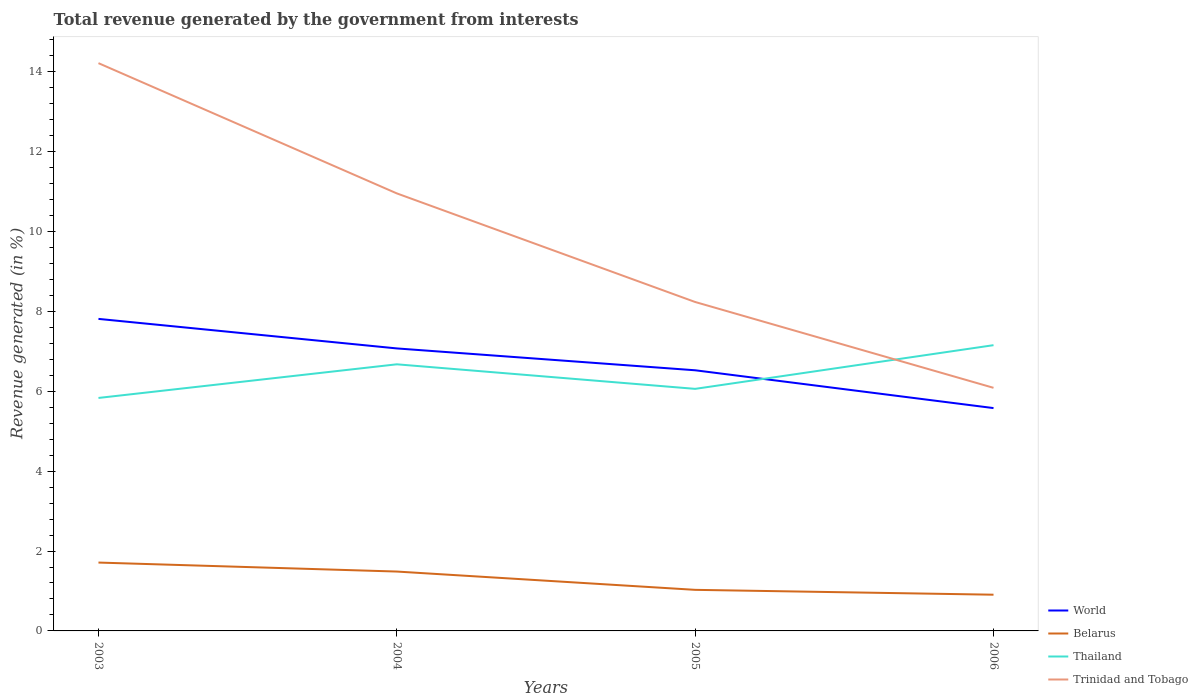Across all years, what is the maximum total revenue generated in Trinidad and Tobago?
Make the answer very short. 6.09. In which year was the total revenue generated in Trinidad and Tobago maximum?
Give a very brief answer. 2006. What is the total total revenue generated in Trinidad and Tobago in the graph?
Your answer should be very brief. 5.98. What is the difference between the highest and the second highest total revenue generated in Belarus?
Your response must be concise. 0.8. What is the difference between the highest and the lowest total revenue generated in Belarus?
Your answer should be compact. 2. How many lines are there?
Offer a terse response. 4. How many years are there in the graph?
Provide a succinct answer. 4. Are the values on the major ticks of Y-axis written in scientific E-notation?
Ensure brevity in your answer.  No. Does the graph contain any zero values?
Give a very brief answer. No. How are the legend labels stacked?
Provide a short and direct response. Vertical. What is the title of the graph?
Provide a short and direct response. Total revenue generated by the government from interests. Does "Libya" appear as one of the legend labels in the graph?
Provide a succinct answer. No. What is the label or title of the Y-axis?
Make the answer very short. Revenue generated (in %). What is the Revenue generated (in %) in World in 2003?
Provide a succinct answer. 7.81. What is the Revenue generated (in %) of Belarus in 2003?
Keep it short and to the point. 1.71. What is the Revenue generated (in %) of Thailand in 2003?
Ensure brevity in your answer.  5.83. What is the Revenue generated (in %) in Trinidad and Tobago in 2003?
Ensure brevity in your answer.  14.21. What is the Revenue generated (in %) in World in 2004?
Make the answer very short. 7.07. What is the Revenue generated (in %) of Belarus in 2004?
Ensure brevity in your answer.  1.49. What is the Revenue generated (in %) in Thailand in 2004?
Provide a succinct answer. 6.67. What is the Revenue generated (in %) in Trinidad and Tobago in 2004?
Offer a terse response. 10.95. What is the Revenue generated (in %) in World in 2005?
Your answer should be very brief. 6.52. What is the Revenue generated (in %) in Belarus in 2005?
Offer a terse response. 1.03. What is the Revenue generated (in %) in Thailand in 2005?
Keep it short and to the point. 6.06. What is the Revenue generated (in %) in Trinidad and Tobago in 2005?
Provide a short and direct response. 8.23. What is the Revenue generated (in %) of World in 2006?
Give a very brief answer. 5.58. What is the Revenue generated (in %) in Belarus in 2006?
Your answer should be compact. 0.91. What is the Revenue generated (in %) in Thailand in 2006?
Your answer should be very brief. 7.15. What is the Revenue generated (in %) of Trinidad and Tobago in 2006?
Your response must be concise. 6.09. Across all years, what is the maximum Revenue generated (in %) of World?
Offer a terse response. 7.81. Across all years, what is the maximum Revenue generated (in %) in Belarus?
Make the answer very short. 1.71. Across all years, what is the maximum Revenue generated (in %) of Thailand?
Your response must be concise. 7.15. Across all years, what is the maximum Revenue generated (in %) in Trinidad and Tobago?
Ensure brevity in your answer.  14.21. Across all years, what is the minimum Revenue generated (in %) in World?
Give a very brief answer. 5.58. Across all years, what is the minimum Revenue generated (in %) in Belarus?
Ensure brevity in your answer.  0.91. Across all years, what is the minimum Revenue generated (in %) of Thailand?
Your response must be concise. 5.83. Across all years, what is the minimum Revenue generated (in %) of Trinidad and Tobago?
Provide a short and direct response. 6.09. What is the total Revenue generated (in %) in World in the graph?
Keep it short and to the point. 26.99. What is the total Revenue generated (in %) of Belarus in the graph?
Your response must be concise. 5.13. What is the total Revenue generated (in %) of Thailand in the graph?
Offer a terse response. 25.72. What is the total Revenue generated (in %) in Trinidad and Tobago in the graph?
Make the answer very short. 39.49. What is the difference between the Revenue generated (in %) of World in 2003 and that in 2004?
Give a very brief answer. 0.74. What is the difference between the Revenue generated (in %) of Belarus in 2003 and that in 2004?
Your answer should be very brief. 0.22. What is the difference between the Revenue generated (in %) of Thailand in 2003 and that in 2004?
Give a very brief answer. -0.84. What is the difference between the Revenue generated (in %) in Trinidad and Tobago in 2003 and that in 2004?
Your answer should be compact. 3.26. What is the difference between the Revenue generated (in %) in World in 2003 and that in 2005?
Offer a terse response. 1.29. What is the difference between the Revenue generated (in %) of Belarus in 2003 and that in 2005?
Give a very brief answer. 0.68. What is the difference between the Revenue generated (in %) of Thailand in 2003 and that in 2005?
Your answer should be very brief. -0.23. What is the difference between the Revenue generated (in %) in Trinidad and Tobago in 2003 and that in 2005?
Ensure brevity in your answer.  5.98. What is the difference between the Revenue generated (in %) of World in 2003 and that in 2006?
Provide a short and direct response. 2.23. What is the difference between the Revenue generated (in %) in Belarus in 2003 and that in 2006?
Your answer should be compact. 0.8. What is the difference between the Revenue generated (in %) of Thailand in 2003 and that in 2006?
Offer a very short reply. -1.32. What is the difference between the Revenue generated (in %) of Trinidad and Tobago in 2003 and that in 2006?
Offer a very short reply. 8.13. What is the difference between the Revenue generated (in %) of World in 2004 and that in 2005?
Ensure brevity in your answer.  0.55. What is the difference between the Revenue generated (in %) of Belarus in 2004 and that in 2005?
Give a very brief answer. 0.46. What is the difference between the Revenue generated (in %) of Thailand in 2004 and that in 2005?
Provide a short and direct response. 0.61. What is the difference between the Revenue generated (in %) in Trinidad and Tobago in 2004 and that in 2005?
Make the answer very short. 2.72. What is the difference between the Revenue generated (in %) in World in 2004 and that in 2006?
Keep it short and to the point. 1.49. What is the difference between the Revenue generated (in %) of Belarus in 2004 and that in 2006?
Provide a succinct answer. 0.58. What is the difference between the Revenue generated (in %) of Thailand in 2004 and that in 2006?
Offer a terse response. -0.48. What is the difference between the Revenue generated (in %) of Trinidad and Tobago in 2004 and that in 2006?
Give a very brief answer. 4.87. What is the difference between the Revenue generated (in %) in World in 2005 and that in 2006?
Offer a terse response. 0.95. What is the difference between the Revenue generated (in %) of Belarus in 2005 and that in 2006?
Your answer should be very brief. 0.12. What is the difference between the Revenue generated (in %) of Thailand in 2005 and that in 2006?
Keep it short and to the point. -1.09. What is the difference between the Revenue generated (in %) in Trinidad and Tobago in 2005 and that in 2006?
Keep it short and to the point. 2.15. What is the difference between the Revenue generated (in %) of World in 2003 and the Revenue generated (in %) of Belarus in 2004?
Provide a short and direct response. 6.33. What is the difference between the Revenue generated (in %) in World in 2003 and the Revenue generated (in %) in Thailand in 2004?
Keep it short and to the point. 1.14. What is the difference between the Revenue generated (in %) in World in 2003 and the Revenue generated (in %) in Trinidad and Tobago in 2004?
Provide a short and direct response. -3.14. What is the difference between the Revenue generated (in %) of Belarus in 2003 and the Revenue generated (in %) of Thailand in 2004?
Provide a succinct answer. -4.96. What is the difference between the Revenue generated (in %) of Belarus in 2003 and the Revenue generated (in %) of Trinidad and Tobago in 2004?
Offer a very short reply. -9.24. What is the difference between the Revenue generated (in %) of Thailand in 2003 and the Revenue generated (in %) of Trinidad and Tobago in 2004?
Your answer should be compact. -5.12. What is the difference between the Revenue generated (in %) in World in 2003 and the Revenue generated (in %) in Belarus in 2005?
Ensure brevity in your answer.  6.78. What is the difference between the Revenue generated (in %) in World in 2003 and the Revenue generated (in %) in Thailand in 2005?
Make the answer very short. 1.75. What is the difference between the Revenue generated (in %) of World in 2003 and the Revenue generated (in %) of Trinidad and Tobago in 2005?
Make the answer very short. -0.42. What is the difference between the Revenue generated (in %) of Belarus in 2003 and the Revenue generated (in %) of Thailand in 2005?
Your answer should be compact. -4.35. What is the difference between the Revenue generated (in %) in Belarus in 2003 and the Revenue generated (in %) in Trinidad and Tobago in 2005?
Offer a terse response. -6.52. What is the difference between the Revenue generated (in %) in Thailand in 2003 and the Revenue generated (in %) in Trinidad and Tobago in 2005?
Offer a terse response. -2.4. What is the difference between the Revenue generated (in %) in World in 2003 and the Revenue generated (in %) in Belarus in 2006?
Your response must be concise. 6.9. What is the difference between the Revenue generated (in %) in World in 2003 and the Revenue generated (in %) in Thailand in 2006?
Keep it short and to the point. 0.66. What is the difference between the Revenue generated (in %) of World in 2003 and the Revenue generated (in %) of Trinidad and Tobago in 2006?
Your answer should be very brief. 1.73. What is the difference between the Revenue generated (in %) in Belarus in 2003 and the Revenue generated (in %) in Thailand in 2006?
Provide a short and direct response. -5.44. What is the difference between the Revenue generated (in %) of Belarus in 2003 and the Revenue generated (in %) of Trinidad and Tobago in 2006?
Make the answer very short. -4.37. What is the difference between the Revenue generated (in %) of Thailand in 2003 and the Revenue generated (in %) of Trinidad and Tobago in 2006?
Offer a terse response. -0.25. What is the difference between the Revenue generated (in %) of World in 2004 and the Revenue generated (in %) of Belarus in 2005?
Give a very brief answer. 6.04. What is the difference between the Revenue generated (in %) in World in 2004 and the Revenue generated (in %) in Thailand in 2005?
Keep it short and to the point. 1.01. What is the difference between the Revenue generated (in %) of World in 2004 and the Revenue generated (in %) of Trinidad and Tobago in 2005?
Provide a short and direct response. -1.16. What is the difference between the Revenue generated (in %) in Belarus in 2004 and the Revenue generated (in %) in Thailand in 2005?
Give a very brief answer. -4.57. What is the difference between the Revenue generated (in %) of Belarus in 2004 and the Revenue generated (in %) of Trinidad and Tobago in 2005?
Offer a very short reply. -6.75. What is the difference between the Revenue generated (in %) of Thailand in 2004 and the Revenue generated (in %) of Trinidad and Tobago in 2005?
Make the answer very short. -1.56. What is the difference between the Revenue generated (in %) in World in 2004 and the Revenue generated (in %) in Belarus in 2006?
Offer a terse response. 6.17. What is the difference between the Revenue generated (in %) of World in 2004 and the Revenue generated (in %) of Thailand in 2006?
Your response must be concise. -0.08. What is the difference between the Revenue generated (in %) of World in 2004 and the Revenue generated (in %) of Trinidad and Tobago in 2006?
Offer a very short reply. 0.99. What is the difference between the Revenue generated (in %) of Belarus in 2004 and the Revenue generated (in %) of Thailand in 2006?
Your response must be concise. -5.67. What is the difference between the Revenue generated (in %) in Belarus in 2004 and the Revenue generated (in %) in Trinidad and Tobago in 2006?
Give a very brief answer. -4.6. What is the difference between the Revenue generated (in %) of Thailand in 2004 and the Revenue generated (in %) of Trinidad and Tobago in 2006?
Offer a very short reply. 0.59. What is the difference between the Revenue generated (in %) in World in 2005 and the Revenue generated (in %) in Belarus in 2006?
Your response must be concise. 5.62. What is the difference between the Revenue generated (in %) of World in 2005 and the Revenue generated (in %) of Thailand in 2006?
Offer a very short reply. -0.63. What is the difference between the Revenue generated (in %) of World in 2005 and the Revenue generated (in %) of Trinidad and Tobago in 2006?
Your answer should be compact. 0.44. What is the difference between the Revenue generated (in %) of Belarus in 2005 and the Revenue generated (in %) of Thailand in 2006?
Your answer should be compact. -6.13. What is the difference between the Revenue generated (in %) of Belarus in 2005 and the Revenue generated (in %) of Trinidad and Tobago in 2006?
Your response must be concise. -5.06. What is the difference between the Revenue generated (in %) of Thailand in 2005 and the Revenue generated (in %) of Trinidad and Tobago in 2006?
Keep it short and to the point. -0.03. What is the average Revenue generated (in %) in World per year?
Your answer should be compact. 6.75. What is the average Revenue generated (in %) of Belarus per year?
Provide a short and direct response. 1.28. What is the average Revenue generated (in %) in Thailand per year?
Give a very brief answer. 6.43. What is the average Revenue generated (in %) of Trinidad and Tobago per year?
Make the answer very short. 9.87. In the year 2003, what is the difference between the Revenue generated (in %) of World and Revenue generated (in %) of Belarus?
Provide a succinct answer. 6.1. In the year 2003, what is the difference between the Revenue generated (in %) in World and Revenue generated (in %) in Thailand?
Ensure brevity in your answer.  1.98. In the year 2003, what is the difference between the Revenue generated (in %) of World and Revenue generated (in %) of Trinidad and Tobago?
Offer a terse response. -6.4. In the year 2003, what is the difference between the Revenue generated (in %) in Belarus and Revenue generated (in %) in Thailand?
Provide a succinct answer. -4.12. In the year 2003, what is the difference between the Revenue generated (in %) in Belarus and Revenue generated (in %) in Trinidad and Tobago?
Give a very brief answer. -12.5. In the year 2003, what is the difference between the Revenue generated (in %) of Thailand and Revenue generated (in %) of Trinidad and Tobago?
Offer a terse response. -8.38. In the year 2004, what is the difference between the Revenue generated (in %) of World and Revenue generated (in %) of Belarus?
Your answer should be very brief. 5.59. In the year 2004, what is the difference between the Revenue generated (in %) of World and Revenue generated (in %) of Thailand?
Make the answer very short. 0.4. In the year 2004, what is the difference between the Revenue generated (in %) in World and Revenue generated (in %) in Trinidad and Tobago?
Give a very brief answer. -3.88. In the year 2004, what is the difference between the Revenue generated (in %) of Belarus and Revenue generated (in %) of Thailand?
Offer a very short reply. -5.19. In the year 2004, what is the difference between the Revenue generated (in %) in Belarus and Revenue generated (in %) in Trinidad and Tobago?
Offer a very short reply. -9.47. In the year 2004, what is the difference between the Revenue generated (in %) of Thailand and Revenue generated (in %) of Trinidad and Tobago?
Provide a short and direct response. -4.28. In the year 2005, what is the difference between the Revenue generated (in %) in World and Revenue generated (in %) in Belarus?
Provide a short and direct response. 5.5. In the year 2005, what is the difference between the Revenue generated (in %) of World and Revenue generated (in %) of Thailand?
Offer a terse response. 0.47. In the year 2005, what is the difference between the Revenue generated (in %) in World and Revenue generated (in %) in Trinidad and Tobago?
Offer a very short reply. -1.71. In the year 2005, what is the difference between the Revenue generated (in %) in Belarus and Revenue generated (in %) in Thailand?
Keep it short and to the point. -5.03. In the year 2005, what is the difference between the Revenue generated (in %) of Belarus and Revenue generated (in %) of Trinidad and Tobago?
Keep it short and to the point. -7.21. In the year 2005, what is the difference between the Revenue generated (in %) of Thailand and Revenue generated (in %) of Trinidad and Tobago?
Ensure brevity in your answer.  -2.17. In the year 2006, what is the difference between the Revenue generated (in %) in World and Revenue generated (in %) in Belarus?
Your response must be concise. 4.67. In the year 2006, what is the difference between the Revenue generated (in %) in World and Revenue generated (in %) in Thailand?
Offer a terse response. -1.58. In the year 2006, what is the difference between the Revenue generated (in %) of World and Revenue generated (in %) of Trinidad and Tobago?
Your response must be concise. -0.51. In the year 2006, what is the difference between the Revenue generated (in %) in Belarus and Revenue generated (in %) in Thailand?
Offer a terse response. -6.25. In the year 2006, what is the difference between the Revenue generated (in %) of Belarus and Revenue generated (in %) of Trinidad and Tobago?
Make the answer very short. -5.18. In the year 2006, what is the difference between the Revenue generated (in %) of Thailand and Revenue generated (in %) of Trinidad and Tobago?
Make the answer very short. 1.07. What is the ratio of the Revenue generated (in %) in World in 2003 to that in 2004?
Your answer should be compact. 1.1. What is the ratio of the Revenue generated (in %) in Belarus in 2003 to that in 2004?
Give a very brief answer. 1.15. What is the ratio of the Revenue generated (in %) in Thailand in 2003 to that in 2004?
Give a very brief answer. 0.87. What is the ratio of the Revenue generated (in %) of Trinidad and Tobago in 2003 to that in 2004?
Provide a succinct answer. 1.3. What is the ratio of the Revenue generated (in %) in World in 2003 to that in 2005?
Make the answer very short. 1.2. What is the ratio of the Revenue generated (in %) in Belarus in 2003 to that in 2005?
Provide a succinct answer. 1.66. What is the ratio of the Revenue generated (in %) of Thailand in 2003 to that in 2005?
Provide a succinct answer. 0.96. What is the ratio of the Revenue generated (in %) of Trinidad and Tobago in 2003 to that in 2005?
Give a very brief answer. 1.73. What is the ratio of the Revenue generated (in %) of World in 2003 to that in 2006?
Offer a very short reply. 1.4. What is the ratio of the Revenue generated (in %) in Belarus in 2003 to that in 2006?
Offer a terse response. 1.89. What is the ratio of the Revenue generated (in %) in Thailand in 2003 to that in 2006?
Give a very brief answer. 0.82. What is the ratio of the Revenue generated (in %) of Trinidad and Tobago in 2003 to that in 2006?
Offer a terse response. 2.34. What is the ratio of the Revenue generated (in %) of World in 2004 to that in 2005?
Your answer should be compact. 1.08. What is the ratio of the Revenue generated (in %) in Belarus in 2004 to that in 2005?
Give a very brief answer. 1.45. What is the ratio of the Revenue generated (in %) in Thailand in 2004 to that in 2005?
Your response must be concise. 1.1. What is the ratio of the Revenue generated (in %) in Trinidad and Tobago in 2004 to that in 2005?
Your answer should be compact. 1.33. What is the ratio of the Revenue generated (in %) in World in 2004 to that in 2006?
Keep it short and to the point. 1.27. What is the ratio of the Revenue generated (in %) of Belarus in 2004 to that in 2006?
Provide a short and direct response. 1.64. What is the ratio of the Revenue generated (in %) of Thailand in 2004 to that in 2006?
Provide a short and direct response. 0.93. What is the ratio of the Revenue generated (in %) in Trinidad and Tobago in 2004 to that in 2006?
Provide a short and direct response. 1.8. What is the ratio of the Revenue generated (in %) of World in 2005 to that in 2006?
Your response must be concise. 1.17. What is the ratio of the Revenue generated (in %) in Belarus in 2005 to that in 2006?
Your answer should be compact. 1.13. What is the ratio of the Revenue generated (in %) in Thailand in 2005 to that in 2006?
Your answer should be very brief. 0.85. What is the ratio of the Revenue generated (in %) of Trinidad and Tobago in 2005 to that in 2006?
Ensure brevity in your answer.  1.35. What is the difference between the highest and the second highest Revenue generated (in %) of World?
Provide a short and direct response. 0.74. What is the difference between the highest and the second highest Revenue generated (in %) of Belarus?
Keep it short and to the point. 0.22. What is the difference between the highest and the second highest Revenue generated (in %) of Thailand?
Your response must be concise. 0.48. What is the difference between the highest and the second highest Revenue generated (in %) of Trinidad and Tobago?
Give a very brief answer. 3.26. What is the difference between the highest and the lowest Revenue generated (in %) in World?
Keep it short and to the point. 2.23. What is the difference between the highest and the lowest Revenue generated (in %) of Belarus?
Offer a terse response. 0.8. What is the difference between the highest and the lowest Revenue generated (in %) of Thailand?
Your answer should be compact. 1.32. What is the difference between the highest and the lowest Revenue generated (in %) in Trinidad and Tobago?
Offer a very short reply. 8.13. 